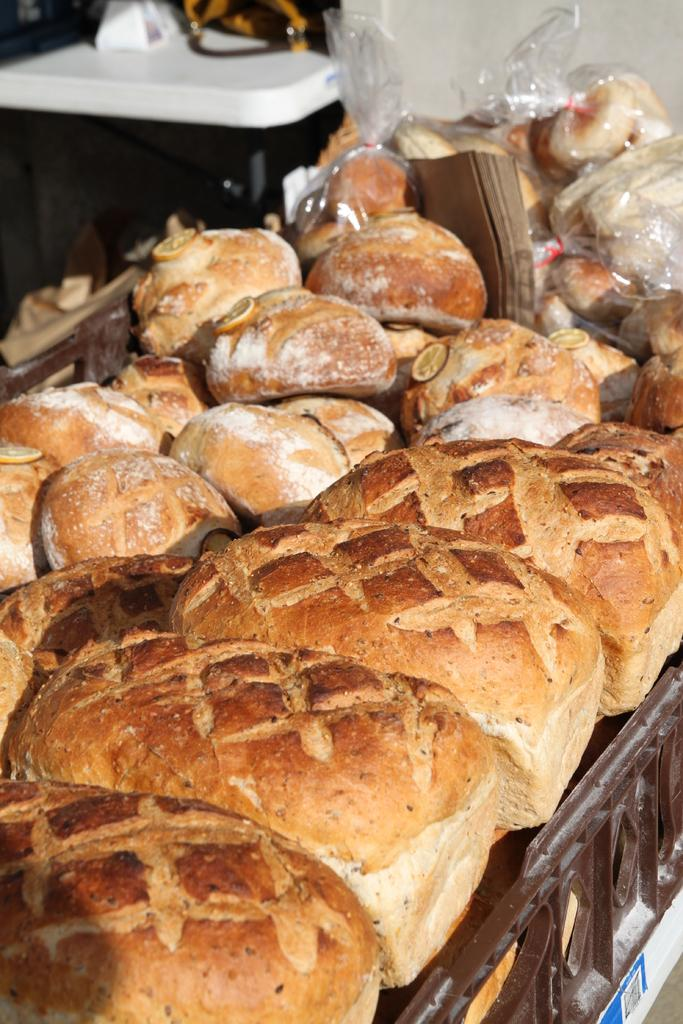What type of food can be seen in the image? There are breads in the image. What might be used to protect or preserve the breads in the image? There are plastic covers in the image. What type of cherry is used as a decoration on the breads in the image? There are no cherries present in the image; it only features breads and plastic covers. 